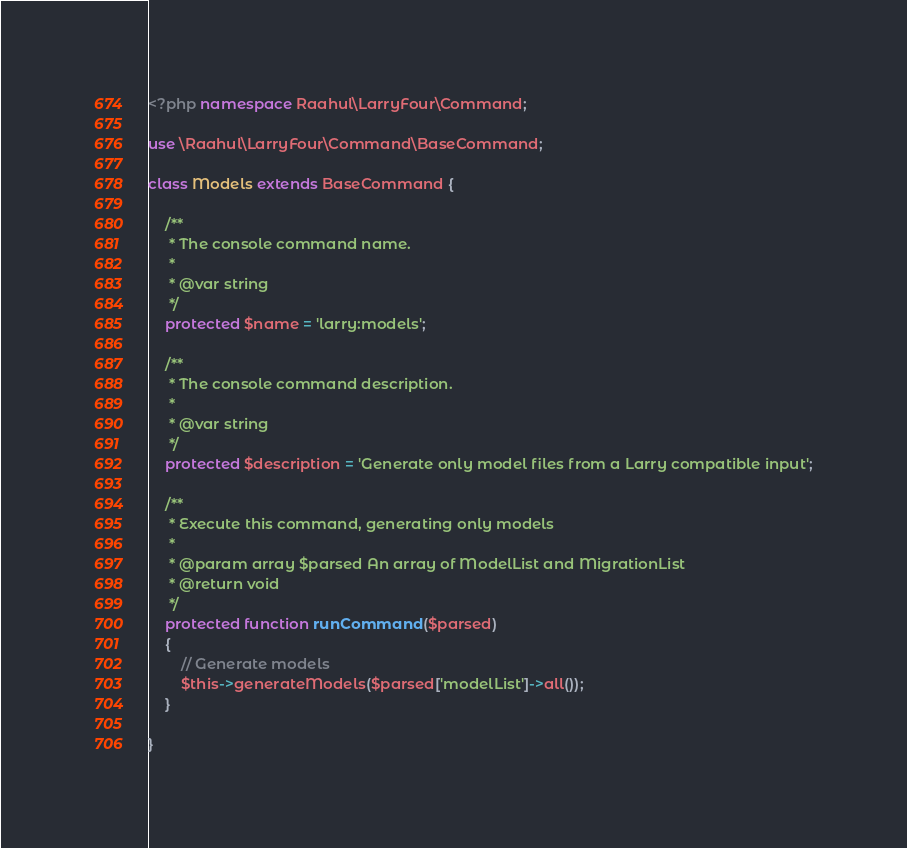Convert code to text. <code><loc_0><loc_0><loc_500><loc_500><_PHP_><?php namespace Raahul\LarryFour\Command;

use \Raahul\LarryFour\Command\BaseCommand;

class Models extends BaseCommand {

    /**
     * The console command name.
     *
     * @var string
     */
    protected $name = 'larry:models';

    /**
     * The console command description.
     *
     * @var string
     */
    protected $description = 'Generate only model files from a Larry compatible input';

    /**
     * Execute this command, generating only models
     *
     * @param array $parsed An array of ModelList and MigrationList
     * @return void
     */
    protected function runCommand($parsed)
    {
        // Generate models
        $this->generateModels($parsed['modelList']->all());
    }

}</code> 